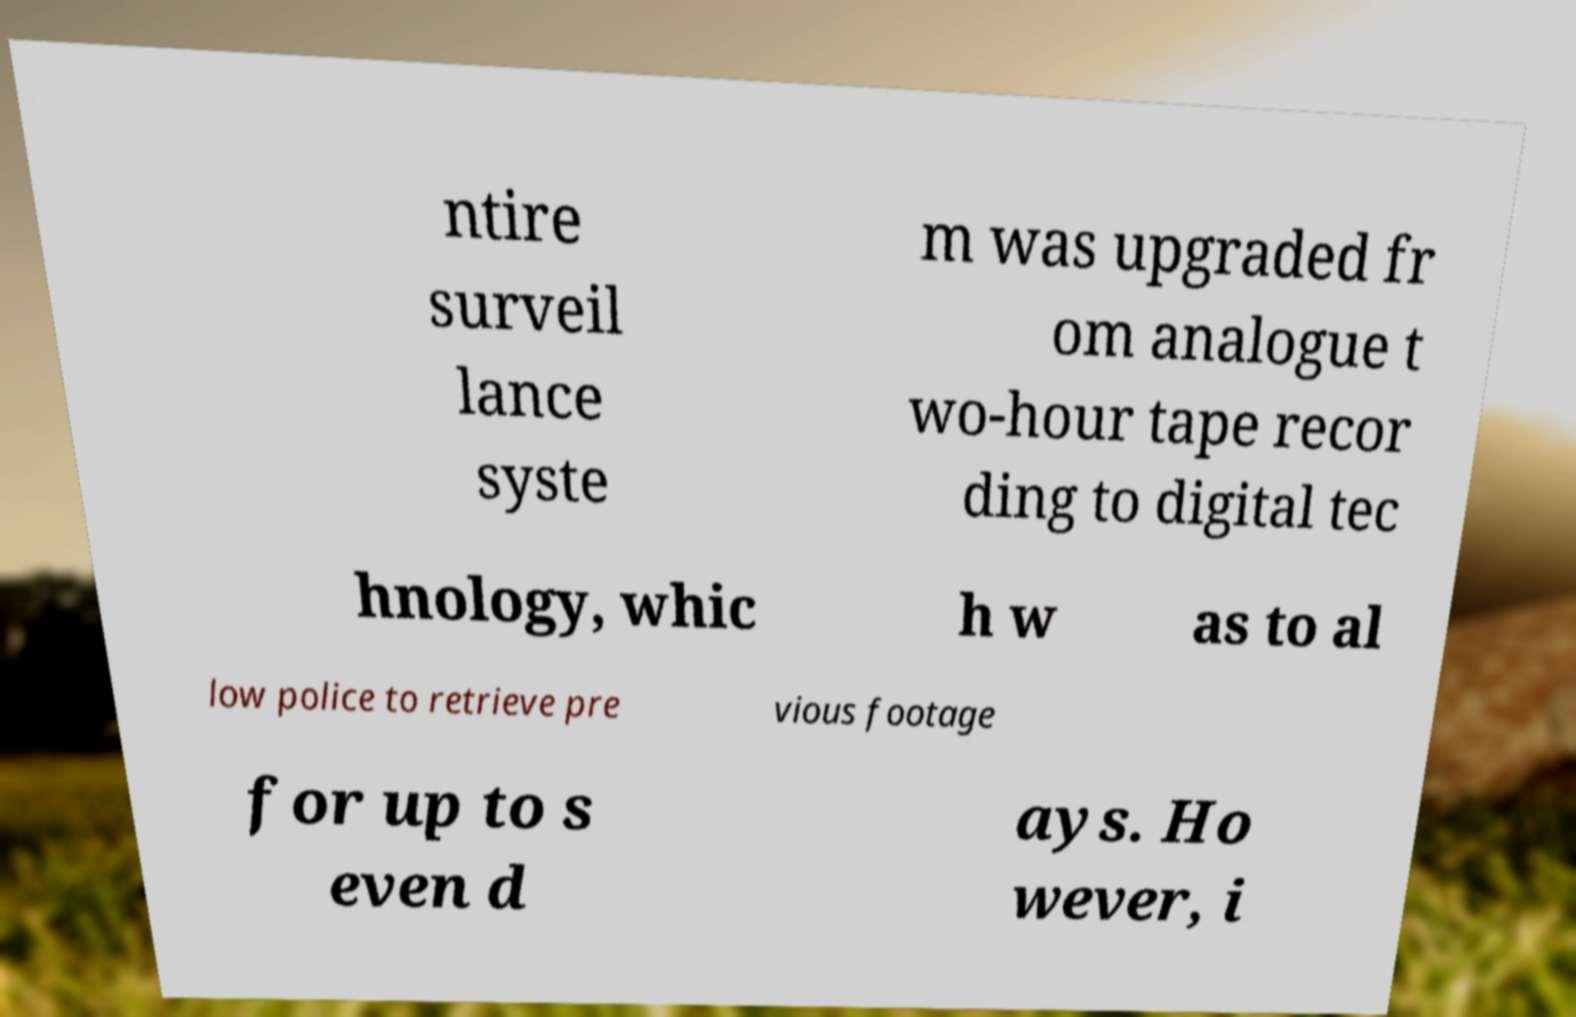What messages or text are displayed in this image? I need them in a readable, typed format. ntire surveil lance syste m was upgraded fr om analogue t wo-hour tape recor ding to digital tec hnology, whic h w as to al low police to retrieve pre vious footage for up to s even d ays. Ho wever, i 